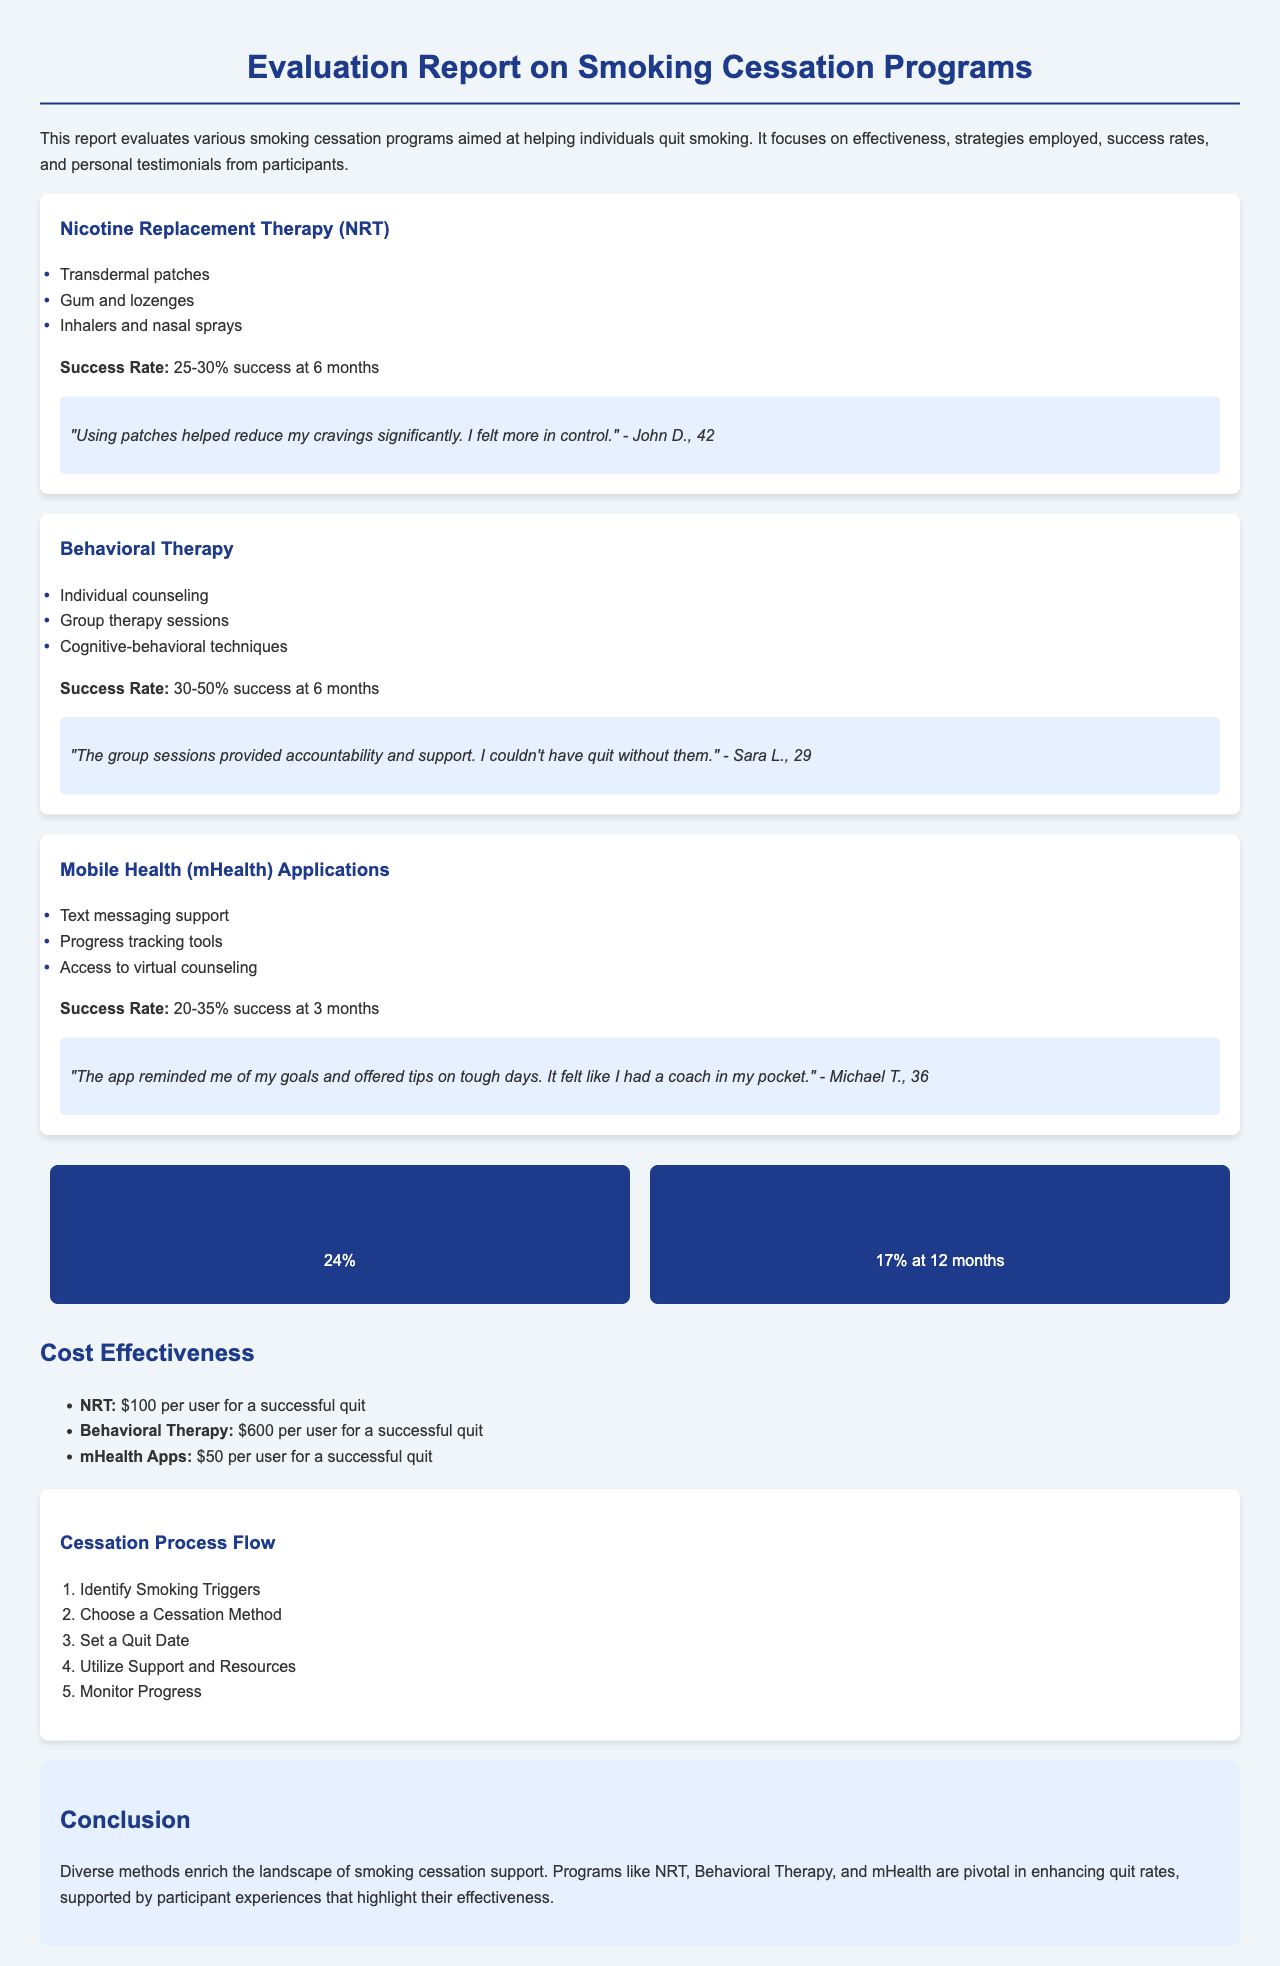what is the success rate of Nicotine Replacement Therapy? The success rate for Nicotine Replacement Therapy at 6 months is mentioned in the document.
Answer: 25-30% what is the primary type of therapy used in Behavioral Therapy programs? Behavioral Therapy programs include individual counseling as one of the strategies used.
Answer: Individual counseling what is the overall success rate of the programs? The overall success rate is provided as a specific percentage in the metrics section of the document.
Answer: 24% which smoking cessation program is the most cost-effective? The cost effectiveness of each program is detailed, and the one with the lowest cost per user is identified.
Answer: mHealth Apps what is the long-term quit rate at 12 months? The document states a specific long-term quit rate at 12 months.
Answer: 17% how does the success rate of Behavioral Therapy compare to Nicotine Replacement Therapy? The success rates for both methods are provided, allowing for comparison between them.
Answer: Higher what is included in the Mobile Health (mHealth) Applications strategy? The strategies employed in mHealth applications is outlined in the document.
Answer: Text messaging support, Progress tracking tools, Access to virtual counseling which participant highlighted the effectiveness of group sessions? A specific testimonial cites a participant who valued group sessions for accountability and support.
Answer: Sara L 